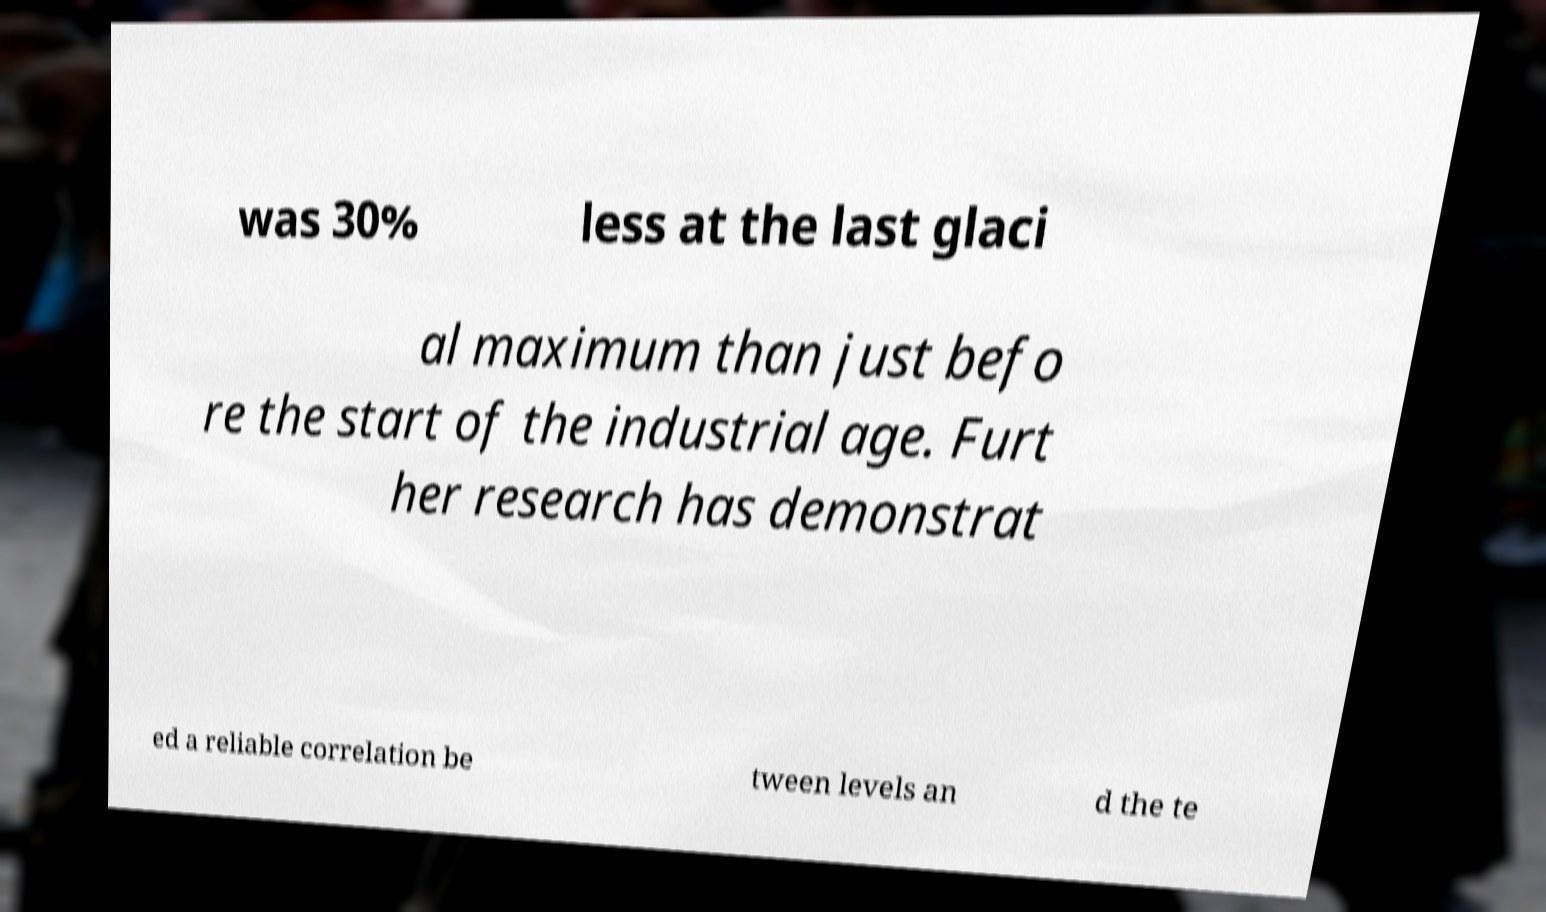Can you read and provide the text displayed in the image?This photo seems to have some interesting text. Can you extract and type it out for me? was 30% less at the last glaci al maximum than just befo re the start of the industrial age. Furt her research has demonstrat ed a reliable correlation be tween levels an d the te 